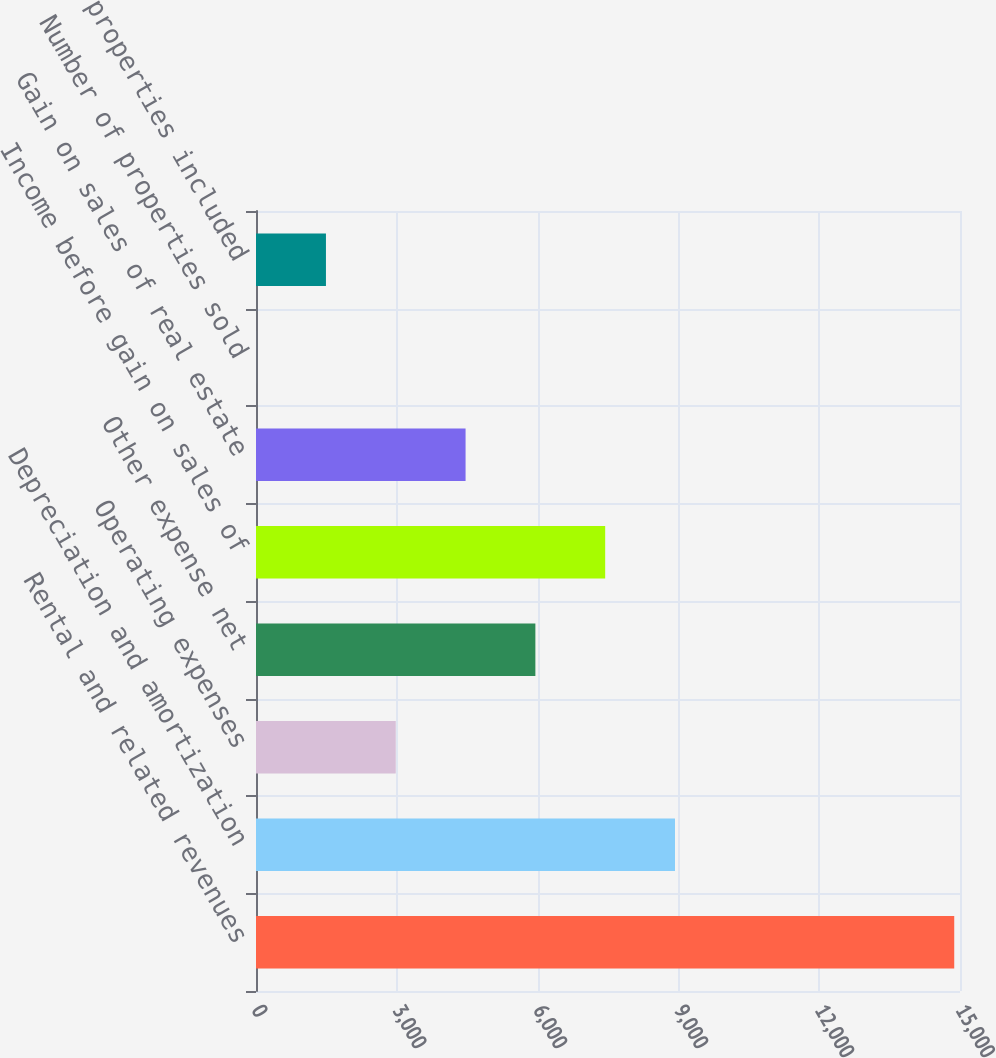<chart> <loc_0><loc_0><loc_500><loc_500><bar_chart><fcel>Rental and related revenues<fcel>Depreciation and amortization<fcel>Operating expenses<fcel>Other expense net<fcel>Income before gain on sales of<fcel>Gain on sales of real estate<fcel>Number of properties sold<fcel>Number of properties included<nl><fcel>14877<fcel>8927.4<fcel>2977.8<fcel>5952.6<fcel>7440<fcel>4465.2<fcel>3<fcel>1490.4<nl></chart> 